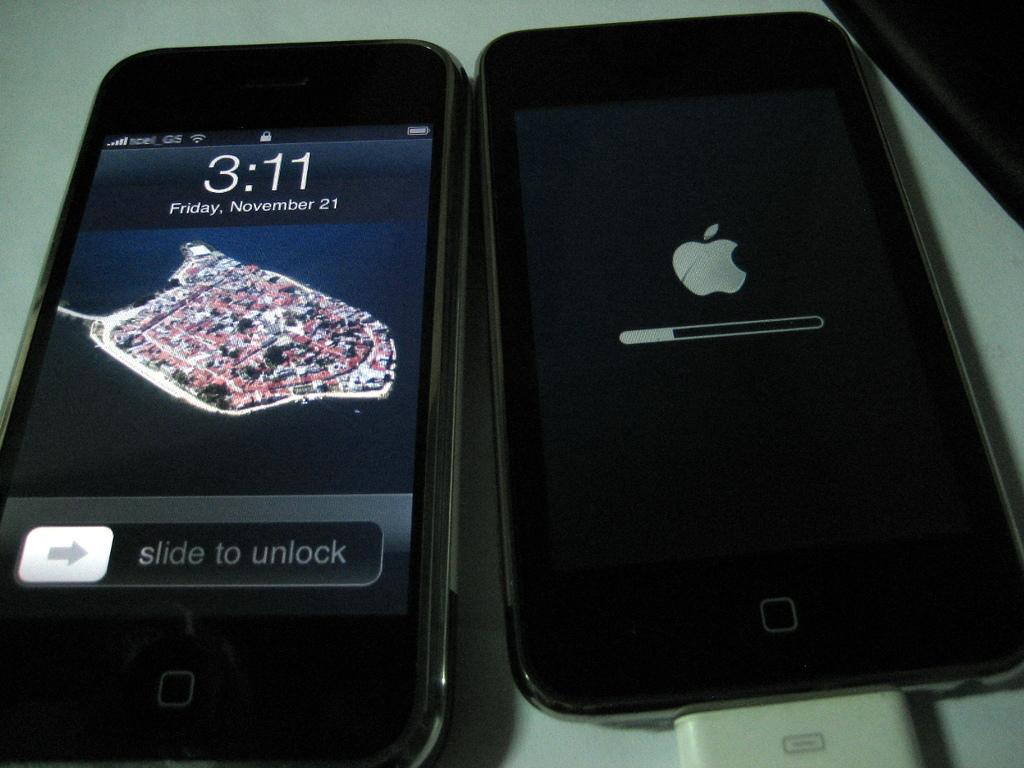Provide a one-sentence caption for the provided image. AN APPLE IPHONE SAYING IT IS FRIDAY NOVEMBER 21. 